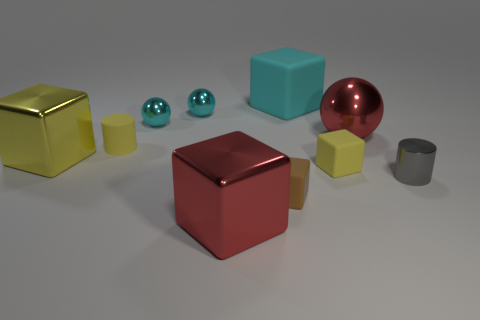Do the small matte thing in front of the gray cylinder and the yellow object that is on the right side of the large cyan matte thing have the same shape?
Offer a very short reply. Yes. The tiny thing that is both on the right side of the cyan block and on the left side of the large red metal ball has what shape?
Ensure brevity in your answer.  Cube. There is a yellow block that is the same material as the small gray thing; what size is it?
Your answer should be compact. Large. Are there fewer tiny matte objects than objects?
Provide a short and direct response. Yes. What material is the big red thing that is in front of the tiny cylinder in front of the small yellow matte object that is in front of the small matte cylinder made of?
Keep it short and to the point. Metal. Does the cylinder left of the cyan cube have the same material as the tiny yellow object that is to the right of the cyan rubber object?
Keep it short and to the point. Yes. What is the size of the yellow object that is right of the yellow shiny block and behind the yellow matte cube?
Give a very brief answer. Small. There is a red cube that is the same size as the cyan matte thing; what is its material?
Make the answer very short. Metal. What number of large things are behind the cylinder right of the large block in front of the brown block?
Give a very brief answer. 3. Do the tiny block to the right of the cyan block and the small cylinder that is to the left of the cyan rubber thing have the same color?
Your answer should be compact. Yes. 